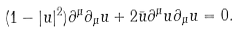Convert formula to latex. <formula><loc_0><loc_0><loc_500><loc_500>( 1 - | u | ^ { 2 } ) \partial ^ { \mu } \partial _ { \mu } u + 2 \bar { u } \partial ^ { \mu } u \partial _ { \mu } u = 0 .</formula> 